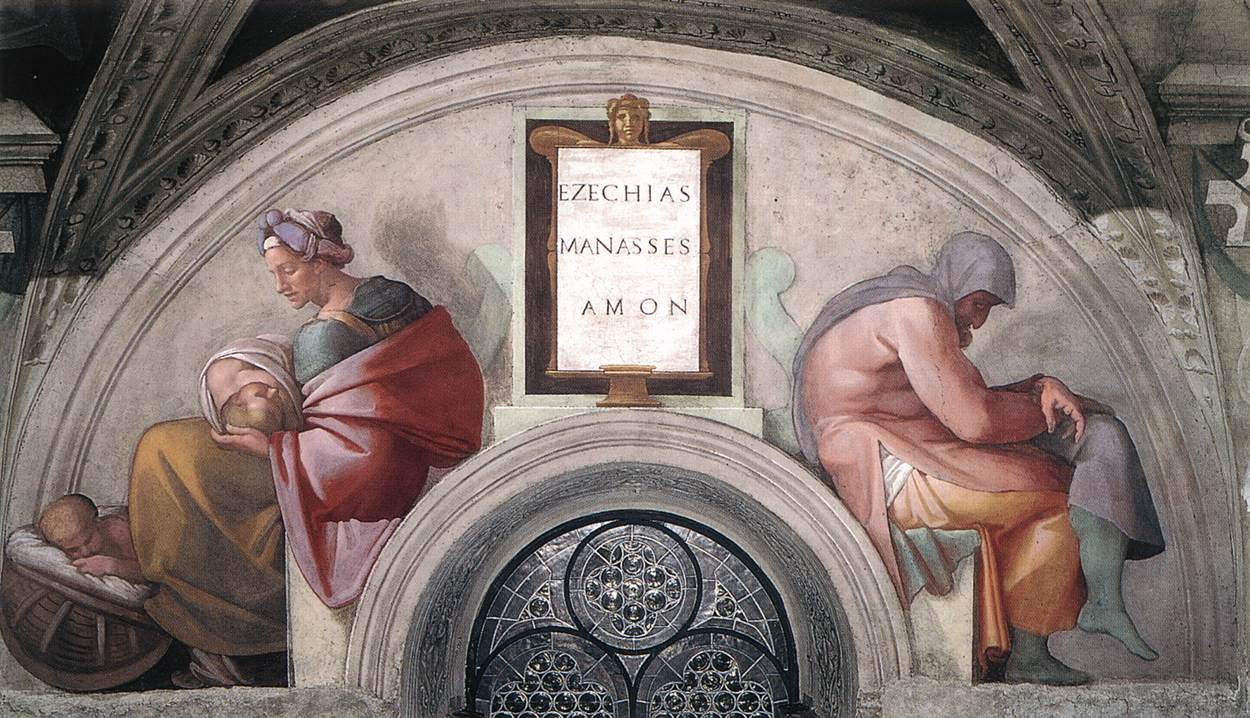Can you describe the symbolic significance of the colors and positioning of the figures? Certainly! In Renaissance art, color often carries symbolic meaning. Red, worn by the central figure, commonly symbolizes passion, sacrifice, or charity, enhancing her presumed role as a caregiver or maternal figure. The blue and yellow on the male figures might represent celestial grace and earthiness or mortality, respectively, suggesting a contrast between the divine and human realms. Positionally, the triangular arrangement with the woman at the apex highlights her as the focal point, perhaps symbolizing a spiritual or moral pinnacle in contrast to the seated men who could be seen as differing paths or choices in life. 